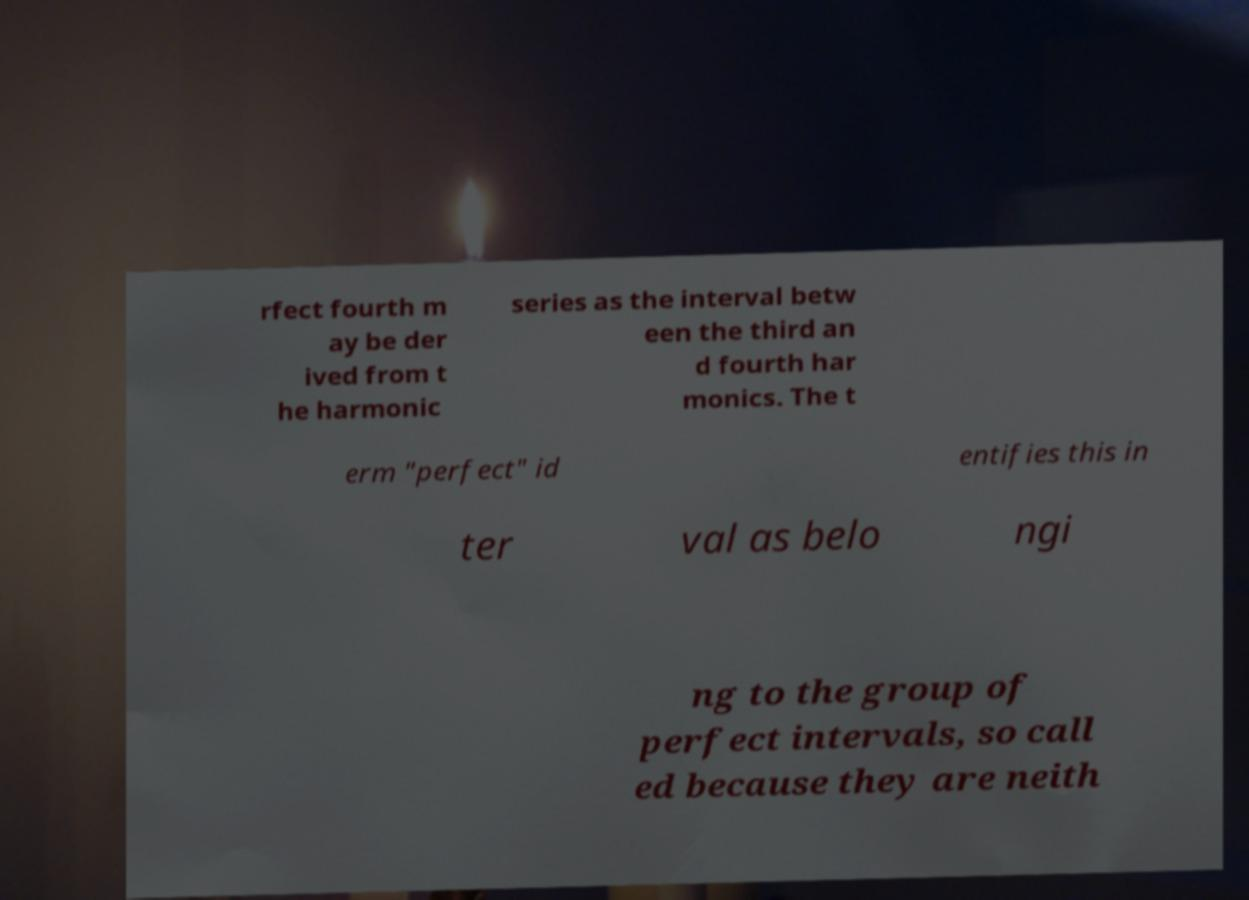I need the written content from this picture converted into text. Can you do that? rfect fourth m ay be der ived from t he harmonic series as the interval betw een the third an d fourth har monics. The t erm "perfect" id entifies this in ter val as belo ngi ng to the group of perfect intervals, so call ed because they are neith 